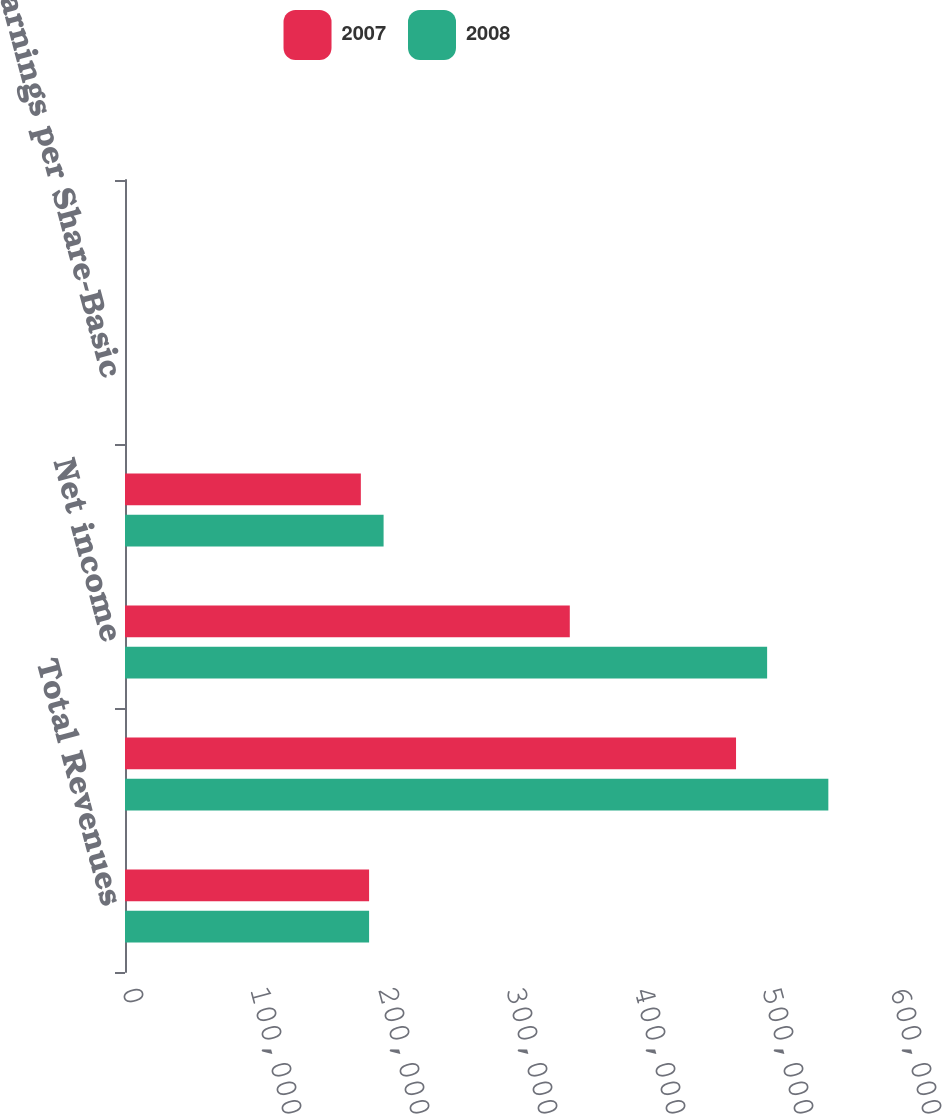Convert chart. <chart><loc_0><loc_0><loc_500><loc_500><stacked_bar_chart><ecel><fcel>Total Revenues<fcel>Income from operations<fcel>Net income<fcel>Weighted-average number of<fcel>Earnings per Share-Basic<fcel>Earnings per Share-Diluted<nl><fcel>2007<fcel>190692<fcel>477373<fcel>347495<fcel>184259<fcel>1.92<fcel>1.89<nl><fcel>2008<fcel>190692<fcel>549482<fcel>501661<fcel>202024<fcel>2.54<fcel>2.48<nl></chart> 